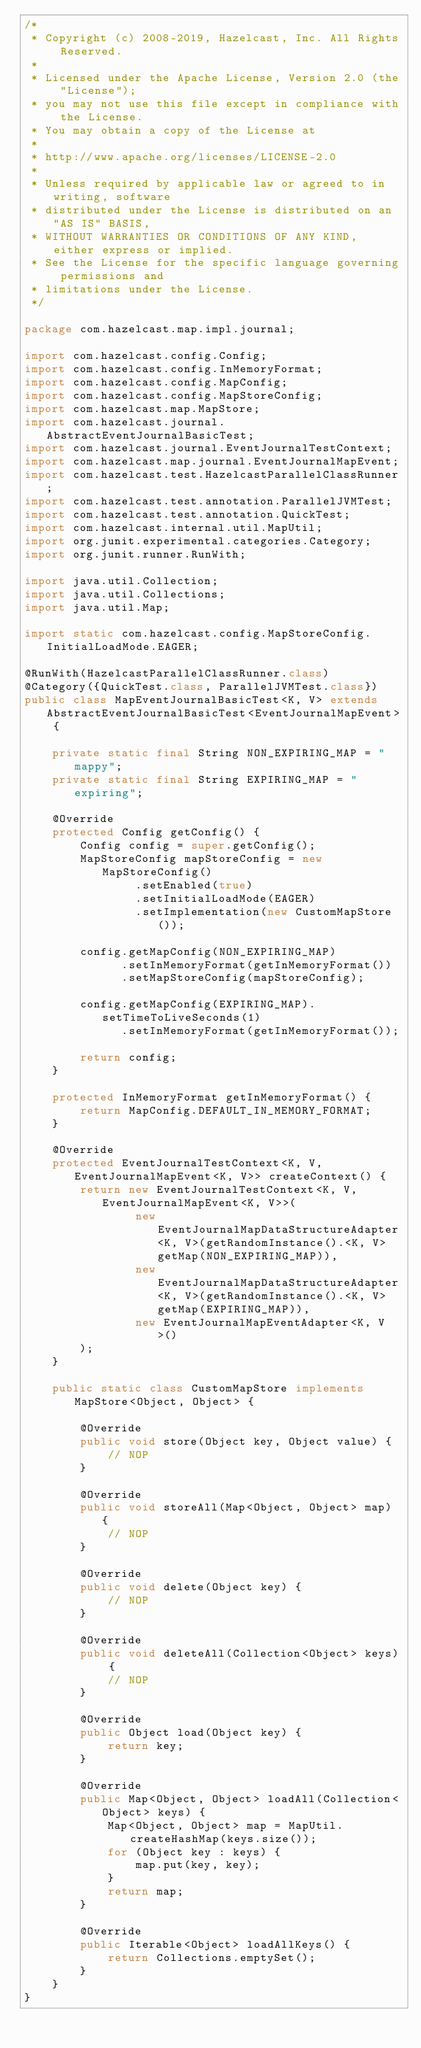<code> <loc_0><loc_0><loc_500><loc_500><_Java_>/*
 * Copyright (c) 2008-2019, Hazelcast, Inc. All Rights Reserved.
 *
 * Licensed under the Apache License, Version 2.0 (the "License");
 * you may not use this file except in compliance with the License.
 * You may obtain a copy of the License at
 *
 * http://www.apache.org/licenses/LICENSE-2.0
 *
 * Unless required by applicable law or agreed to in writing, software
 * distributed under the License is distributed on an "AS IS" BASIS,
 * WITHOUT WARRANTIES OR CONDITIONS OF ANY KIND, either express or implied.
 * See the License for the specific language governing permissions and
 * limitations under the License.
 */

package com.hazelcast.map.impl.journal;

import com.hazelcast.config.Config;
import com.hazelcast.config.InMemoryFormat;
import com.hazelcast.config.MapConfig;
import com.hazelcast.config.MapStoreConfig;
import com.hazelcast.map.MapStore;
import com.hazelcast.journal.AbstractEventJournalBasicTest;
import com.hazelcast.journal.EventJournalTestContext;
import com.hazelcast.map.journal.EventJournalMapEvent;
import com.hazelcast.test.HazelcastParallelClassRunner;
import com.hazelcast.test.annotation.ParallelJVMTest;
import com.hazelcast.test.annotation.QuickTest;
import com.hazelcast.internal.util.MapUtil;
import org.junit.experimental.categories.Category;
import org.junit.runner.RunWith;

import java.util.Collection;
import java.util.Collections;
import java.util.Map;

import static com.hazelcast.config.MapStoreConfig.InitialLoadMode.EAGER;

@RunWith(HazelcastParallelClassRunner.class)
@Category({QuickTest.class, ParallelJVMTest.class})
public class MapEventJournalBasicTest<K, V> extends AbstractEventJournalBasicTest<EventJournalMapEvent> {

    private static final String NON_EXPIRING_MAP = "mappy";
    private static final String EXPIRING_MAP = "expiring";

    @Override
    protected Config getConfig() {
        Config config = super.getConfig();
        MapStoreConfig mapStoreConfig = new MapStoreConfig()
                .setEnabled(true)
                .setInitialLoadMode(EAGER)
                .setImplementation(new CustomMapStore());

        config.getMapConfig(NON_EXPIRING_MAP)
              .setInMemoryFormat(getInMemoryFormat())
              .setMapStoreConfig(mapStoreConfig);

        config.getMapConfig(EXPIRING_MAP).setTimeToLiveSeconds(1)
              .setInMemoryFormat(getInMemoryFormat());

        return config;
    }

    protected InMemoryFormat getInMemoryFormat() {
        return MapConfig.DEFAULT_IN_MEMORY_FORMAT;
    }

    @Override
    protected EventJournalTestContext<K, V, EventJournalMapEvent<K, V>> createContext() {
        return new EventJournalTestContext<K, V, EventJournalMapEvent<K, V>>(
                new EventJournalMapDataStructureAdapter<K, V>(getRandomInstance().<K, V>getMap(NON_EXPIRING_MAP)),
                new EventJournalMapDataStructureAdapter<K, V>(getRandomInstance().<K, V>getMap(EXPIRING_MAP)),
                new EventJournalMapEventAdapter<K, V>()
        );
    }

    public static class CustomMapStore implements MapStore<Object, Object> {

        @Override
        public void store(Object key, Object value) {
            // NOP
        }

        @Override
        public void storeAll(Map<Object, Object> map) {
            // NOP
        }

        @Override
        public void delete(Object key) {
            // NOP
        }

        @Override
        public void deleteAll(Collection<Object> keys) {
            // NOP
        }

        @Override
        public Object load(Object key) {
            return key;
        }

        @Override
        public Map<Object, Object> loadAll(Collection<Object> keys) {
            Map<Object, Object> map = MapUtil.createHashMap(keys.size());
            for (Object key : keys) {
                map.put(key, key);
            }
            return map;
        }

        @Override
        public Iterable<Object> loadAllKeys() {
            return Collections.emptySet();
        }
    }
}
</code> 